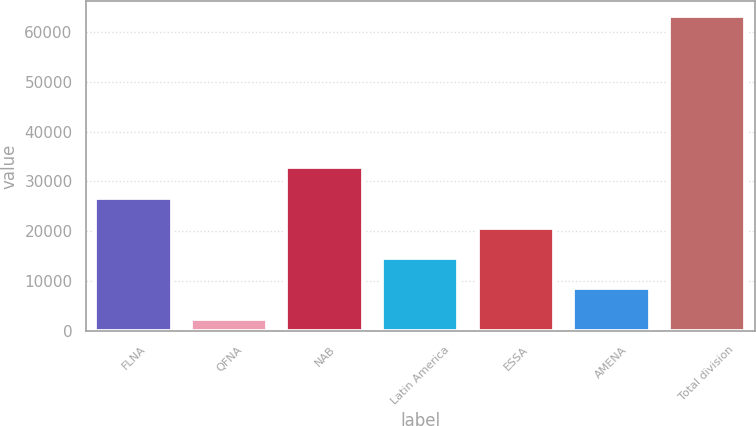Convert chart to OTSL. <chart><loc_0><loc_0><loc_500><loc_500><bar_chart><fcel>FLNA<fcel>QFNA<fcel>NAB<fcel>Latin America<fcel>ESSA<fcel>AMENA<fcel>Total division<nl><fcel>26748.2<fcel>2543<fcel>32799.5<fcel>14645.6<fcel>20696.9<fcel>8594.3<fcel>63056<nl></chart> 